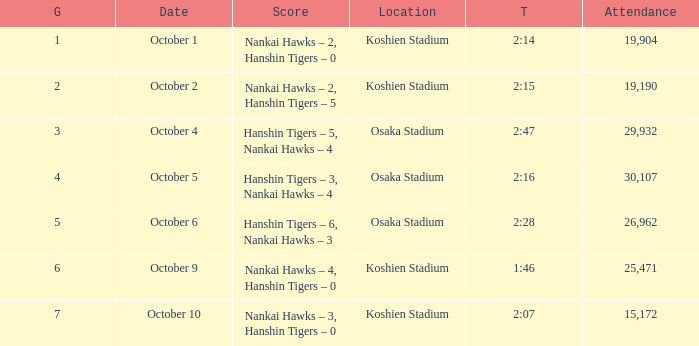In how many games is the attendance figure 19,190? 1.0. 